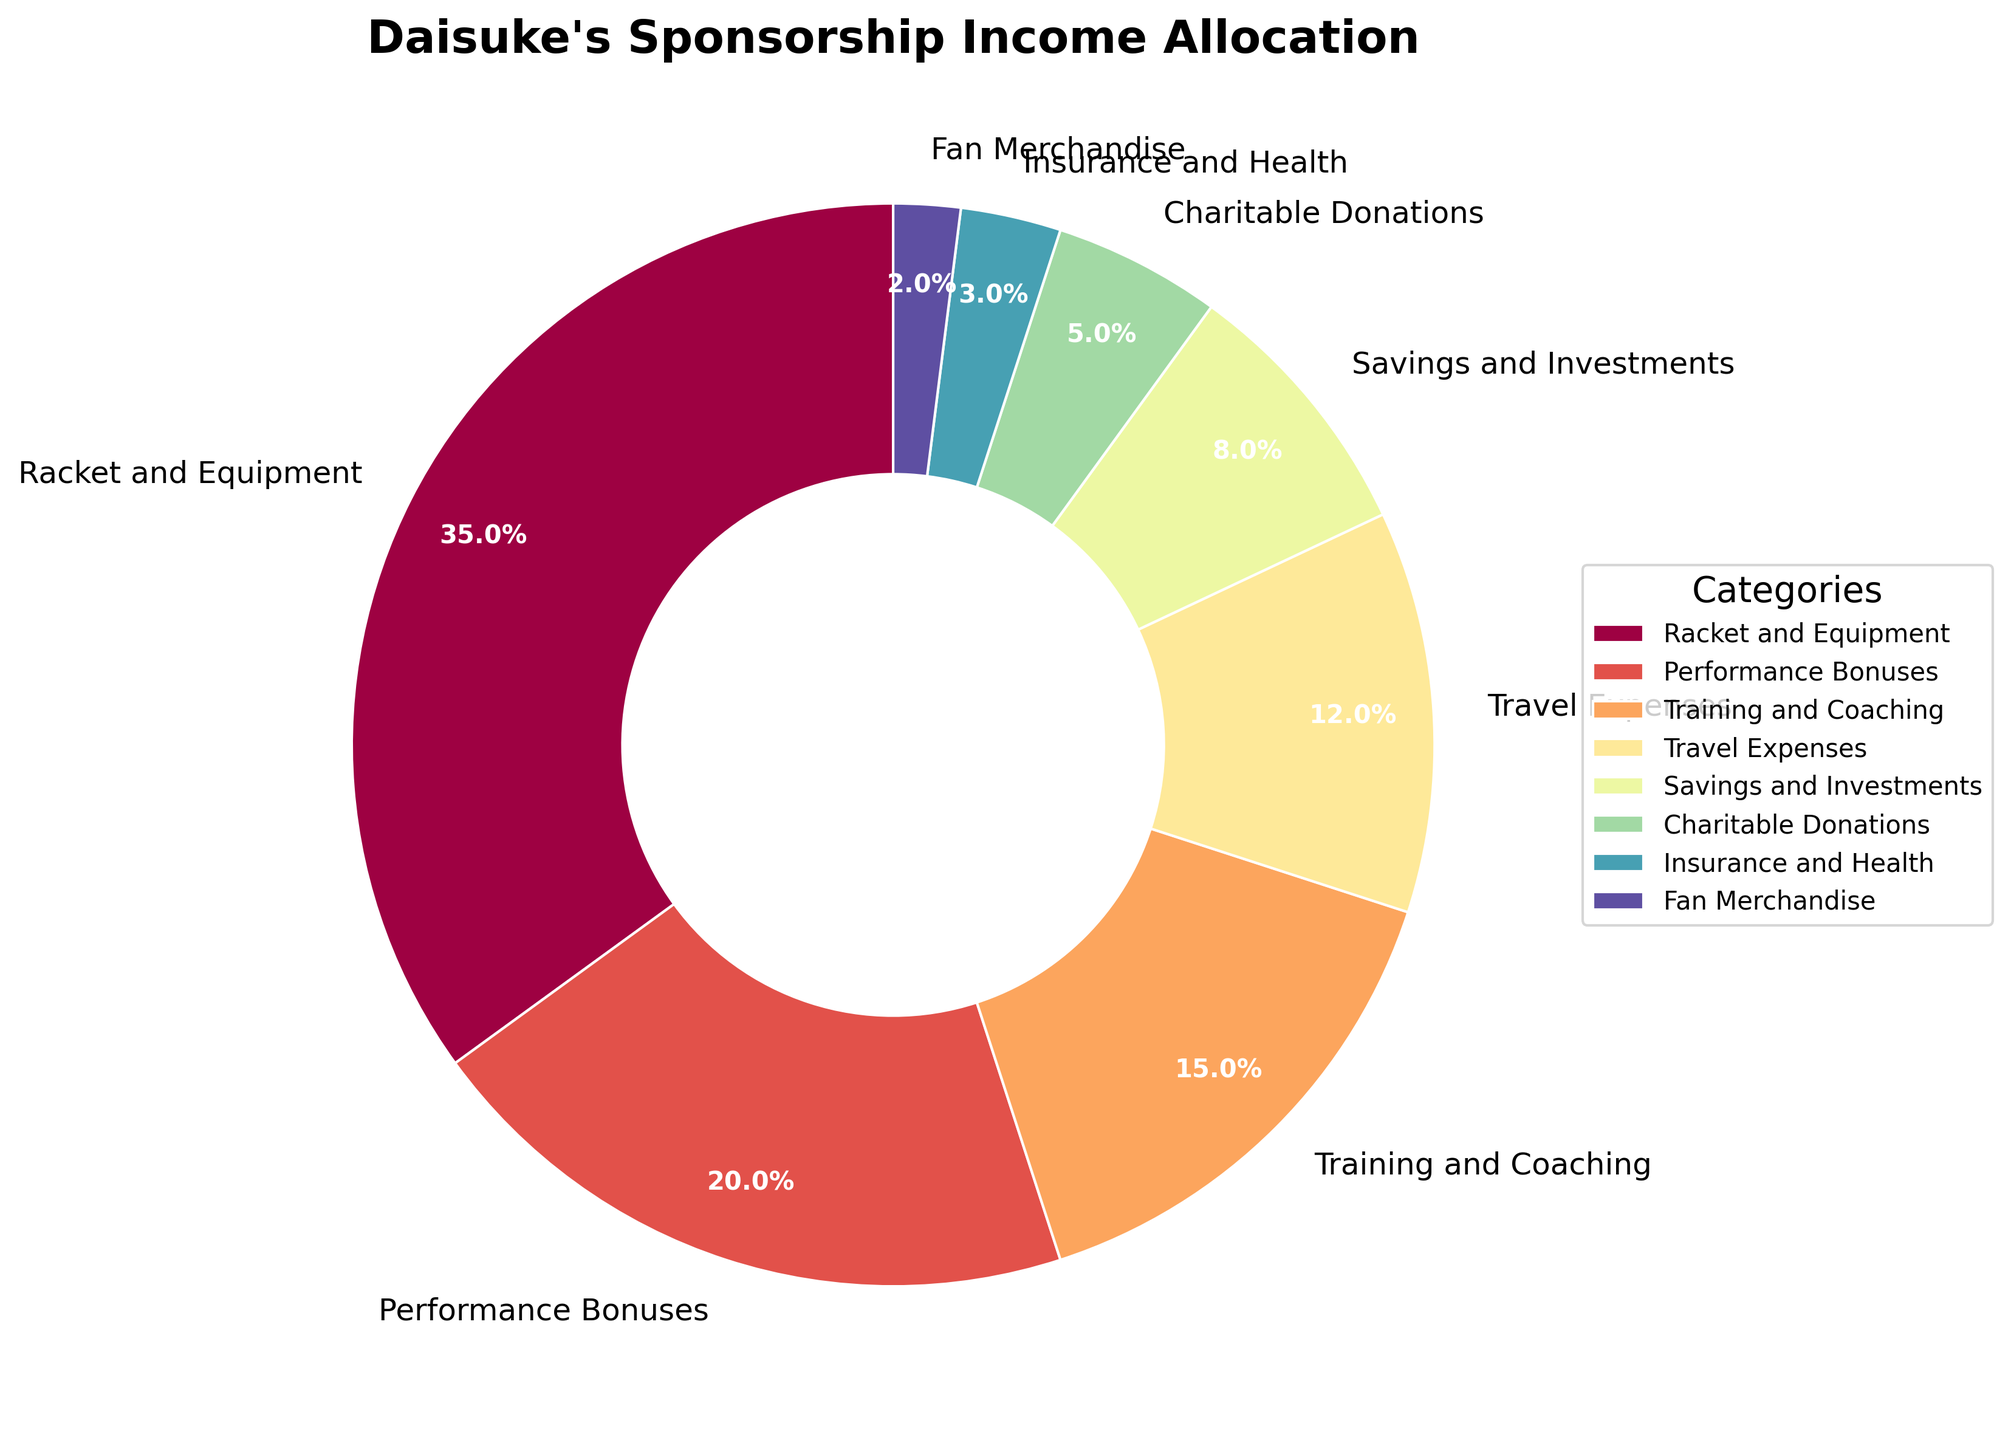What percentage of Daisuke's sponsorship income goes toward Training and Coaching and Travel Expenses combined? To find the total percentage allocated to Training and Coaching and Travel Expenses, add their individual percentages: Training and Coaching (15%) + Travel Expenses (12%) = 27%.
Answer: 27% Which category gets the highest percentage of Daisuke's sponsorship income? By looking at the pie chart, identify the category with the largest segment. The largest segment represents Racket and Equipment at 35%.
Answer: Racket and Equipment Between Savings and Investments and Insurance and Health, which category receives more of Daisuke's sponsorship income, and by how much? Compare the percentages of Savings and Investments (8%) and Insurance and Health (3%). The difference is calculated by subtracting the smaller percentage from the larger one: 8% - 3% = 5%. Savings and Investments receives 5% more.
Answer: Savings and Investments by 5% What fraction of Daisuke's sponsorship income is allocated to Racket and Equipment and Performance Bonuses together? Add the percentages of Racket and Equipment (35%) and Performance Bonuses (20%). The combined fraction is 35% + 20% = 55%.
Answer: 55% Is the percentage of sponsorship income allocated to Travel Expenses greater than that for Savings and Investments? Compare the percentages: Travel Expenses (12%) and Savings and Investments (8%). Since 12% > 8%, Travel Expenses is greater.
Answer: Yes How much more percentage does Daisuke allocate to Performance Bonuses than to Fan Merchandise? Subtract the percentage of Fan Merchandise (2%) from the percentage of Performance Bonuses (20%): 20% - 2% = 18%.
Answer: 18% Are the combined percentages of Charitable Donations and Insurance and Health equal to or less than the percentage for Training and Coaching? Add the percentages of Charitable Donations (5%) and Insurance and Health (3%): 5% + 3% = 8%. Compare 8% with Training and Coaching (15%). 8% is less than 15%.
Answer: Less than Which segments in the pie chart are smaller than Training and Coaching? Any segment less than 15% is smaller. These segments are Travel Expenses (12%), Savings and Investments (8%), Charitable Donations (5%), Insurance and Health (3%), and Fan Merchandise (2%).
Answer: Travel Expenses, Savings and Investments, Charitable Donations, Insurance and Health, Fan Merchandise What combined percentage of Daisuke's sponsorship income is allocated to categories other than the top two largest segments? First, identify the top two segments: Racket and Equipment (35%) and Performance Bonuses (20%). Combine the remaining percentages: Training and Coaching (15%) + Travel Expenses (12%) + Savings and Investments (8%) + Charitable Donations (5%) + Insurance and Health (3%) + Fan Merchandise (2%) = 45%.
Answer: 45% Which category gets exactly a fifth of Daisuke's sponsorship income? A fifth is equal to 20%. Identify the category with this percentage. Performance Bonuses is 20%.
Answer: Performance Bonuses 